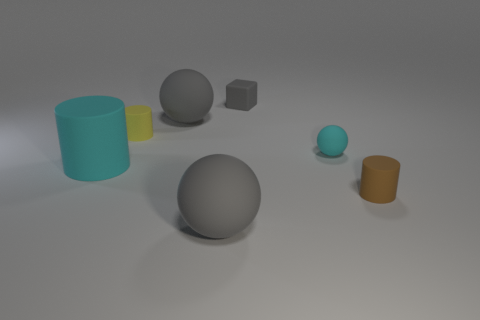Add 3 big yellow matte objects. How many objects exist? 10 Subtract all cubes. How many objects are left? 6 Subtract 1 brown cylinders. How many objects are left? 6 Subtract all gray objects. Subtract all brown rubber cylinders. How many objects are left? 3 Add 1 large things. How many large things are left? 4 Add 3 large cyan cylinders. How many large cyan cylinders exist? 4 